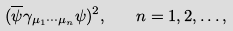<formula> <loc_0><loc_0><loc_500><loc_500>( \overline { \psi } \gamma _ { \mu _ { 1 } \cdots \mu _ { n } } \psi ) ^ { 2 } , \quad n = 1 , 2 , \dots ,</formula> 